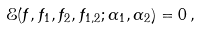Convert formula to latex. <formula><loc_0><loc_0><loc_500><loc_500>\mathcal { E } ( f , f _ { 1 } , f _ { 2 } , f _ { 1 , 2 } ; \alpha _ { 1 } , \alpha _ { 2 } ) = 0 \, ,</formula> 